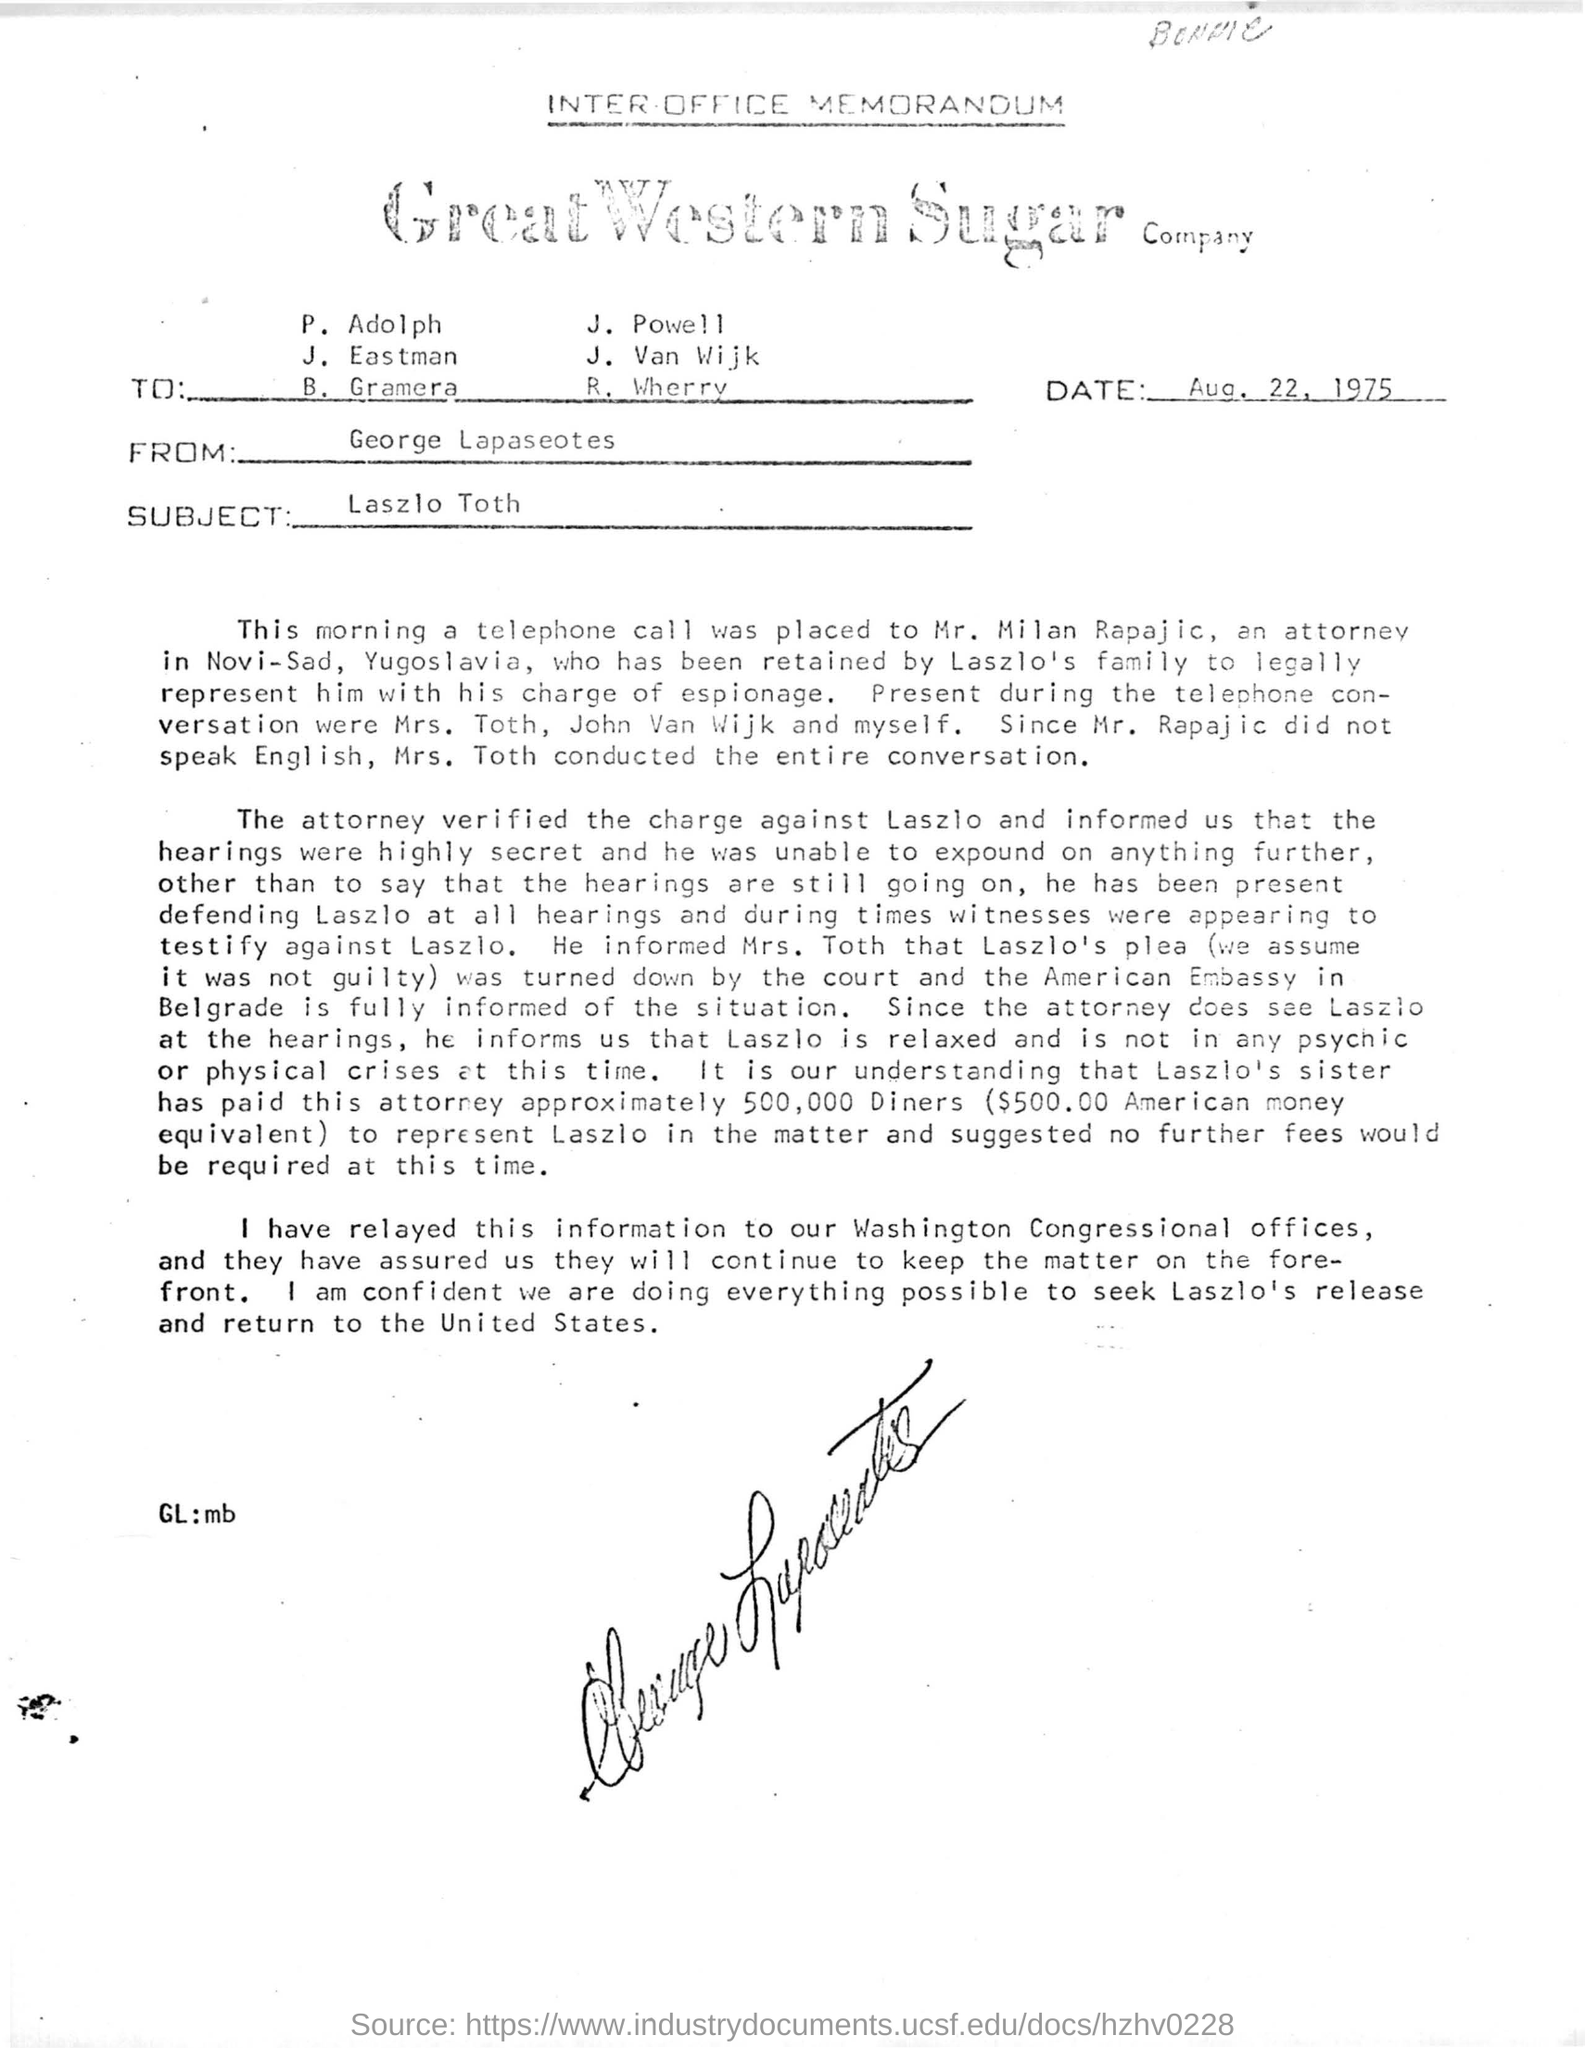Highlight a few significant elements in this photo. The memorandum is sent to George Lapaseotes. The memorandum's date is August 22, 1975. The subject of the memorandum is Laszlo Toth. 